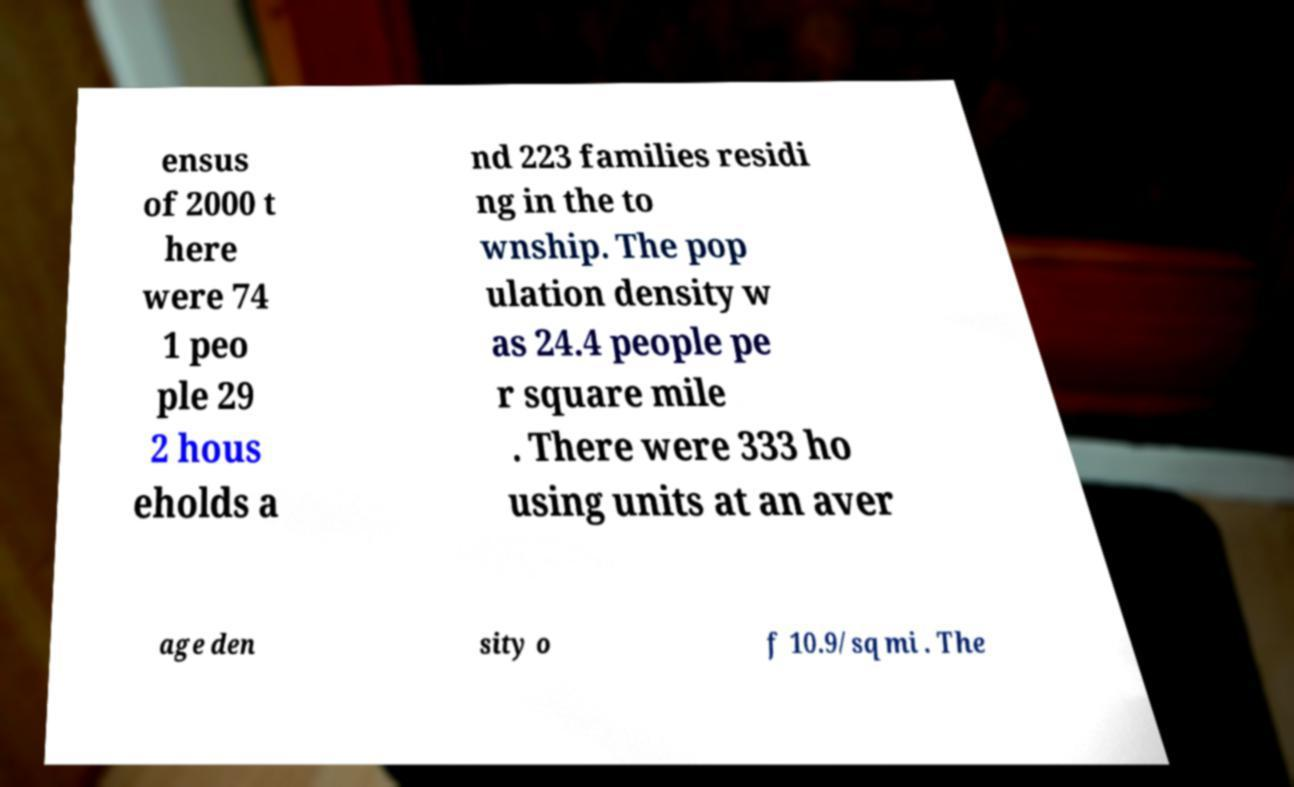Could you extract and type out the text from this image? ensus of 2000 t here were 74 1 peo ple 29 2 hous eholds a nd 223 families residi ng in the to wnship. The pop ulation density w as 24.4 people pe r square mile . There were 333 ho using units at an aver age den sity o f 10.9/sq mi . The 